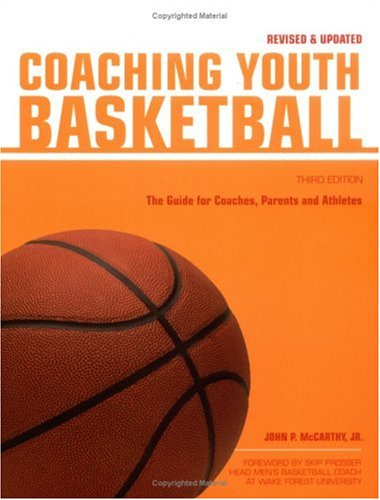What is the title of this book? The title of the book, written across the top of its cover, is 'Coaching Youth Basketball: The Guide for Coaches & Parents (Betterway Coaching Kids),' Third Edition. 